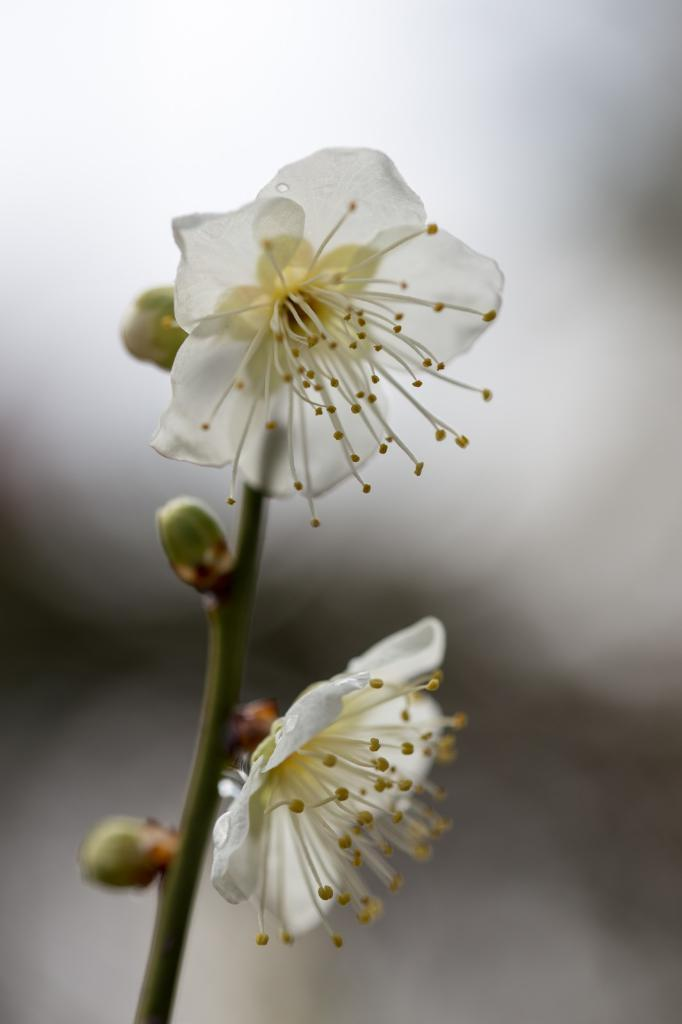How many flowers can be seen in the image? There are two white flowers in the image. What is the relationship between the flowers and the stem? The flowers are attached to a stem. What is the growth stage of some parts of the flowers? There are buds in the image. Can you describe the background of the image? The backdrop of the image is blurred. What type of chin can be seen on the door in the image? There is no door or chin present in the image; it features two white flowers with a blurred backdrop. 